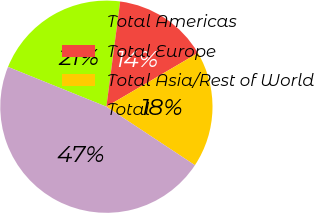Convert chart to OTSL. <chart><loc_0><loc_0><loc_500><loc_500><pie_chart><fcel>Total Americas<fcel>Total Europe<fcel>Total Asia/Rest of World<fcel>Total<nl><fcel>20.96%<fcel>14.49%<fcel>17.73%<fcel>46.82%<nl></chart> 